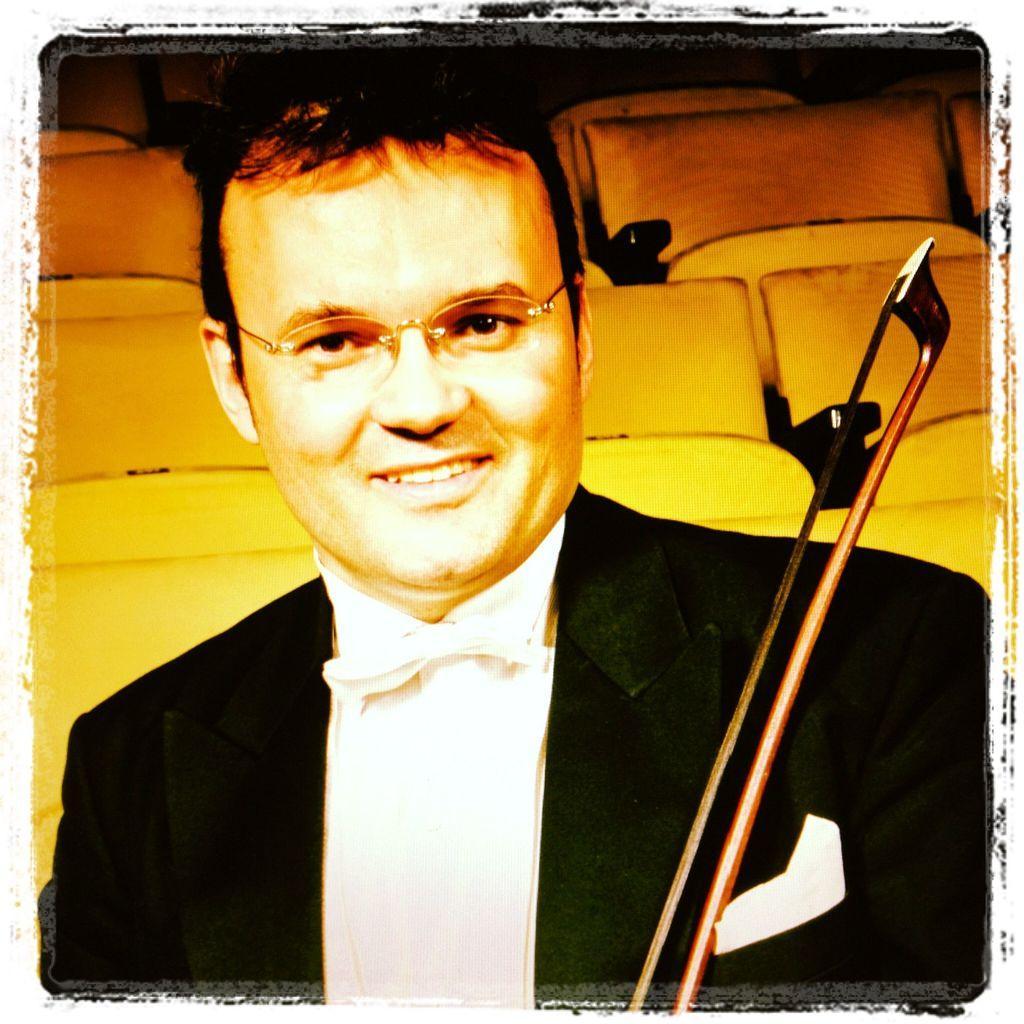Please provide a concise description of this image. This is an edited image with the borders. In the foreground there is a person wearing suit and we can see an object. In the background we can see the chairs. 